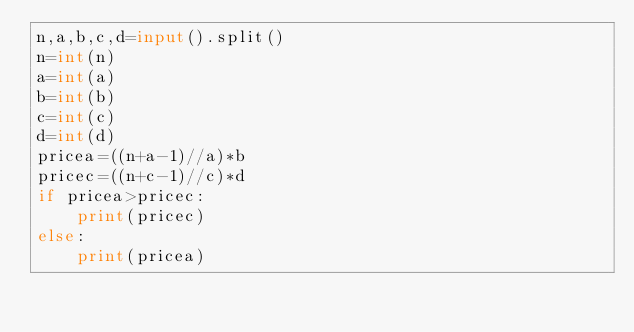Convert code to text. <code><loc_0><loc_0><loc_500><loc_500><_Python_>n,a,b,c,d=input().split()
n=int(n)
a=int(a)
b=int(b)
c=int(c)
d=int(d)
pricea=((n+a-1)//a)*b
pricec=((n+c-1)//c)*d
if pricea>pricec:
    print(pricec)
else:
    print(pricea)
</code> 